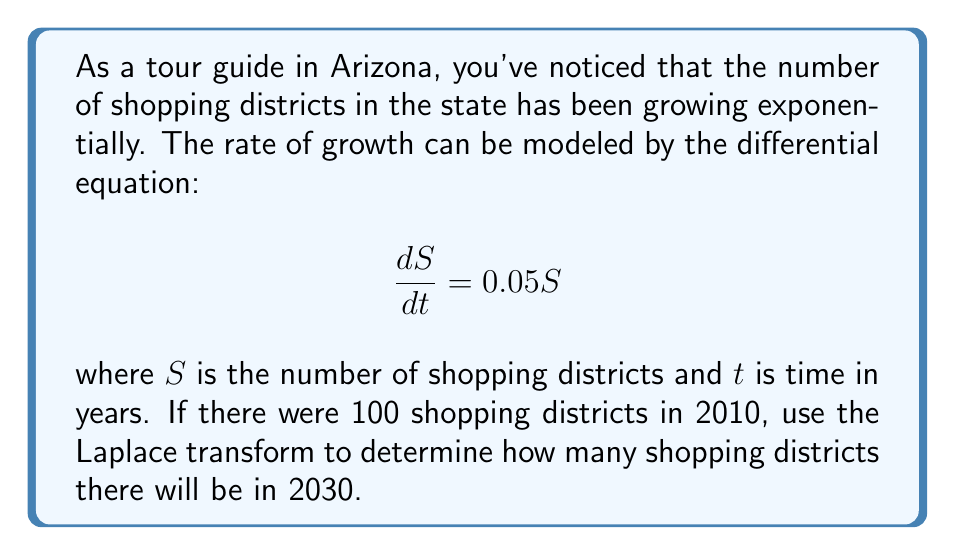Give your solution to this math problem. Let's solve this step-by-step using Laplace transforms:

1) First, we need to set up our initial value problem:
   $$\frac{dS}{dt} = 0.05S$$
   $$S(0) = 100$$ (since we're starting our count from 2010)

2) Take the Laplace transform of both sides:
   $$\mathcal{L}\left\{\frac{dS}{dt}\right\} = \mathcal{L}\{0.05S\}$$

3) Using the Laplace transform properties:
   $$s\mathcal{L}\{S\} - S(0) = 0.05\mathcal{L}\{S\}$$

4) Let $\mathcal{L}\{S\} = X(s)$:
   $$sX(s) - 100 = 0.05X(s)$$

5) Solve for $X(s)$:
   $$sX(s) - 0.05X(s) = 100$$
   $$X(s)(s - 0.05) = 100$$
   $$X(s) = \frac{100}{s - 0.05}$$

6) Take the inverse Laplace transform:
   $$S(t) = \mathcal{L}^{-1}\left\{\frac{100}{s - 0.05}\right\} = 100e^{0.05t}$$

7) To find the number of shopping districts in 2030, we need to evaluate $S(20)$:
   $$S(20) = 100e^{0.05(20)} = 100e^{1} \approx 271.83$$

Therefore, in 2030 (20 years after 2010), there will be approximately 272 shopping districts.
Answer: 272 shopping districts 